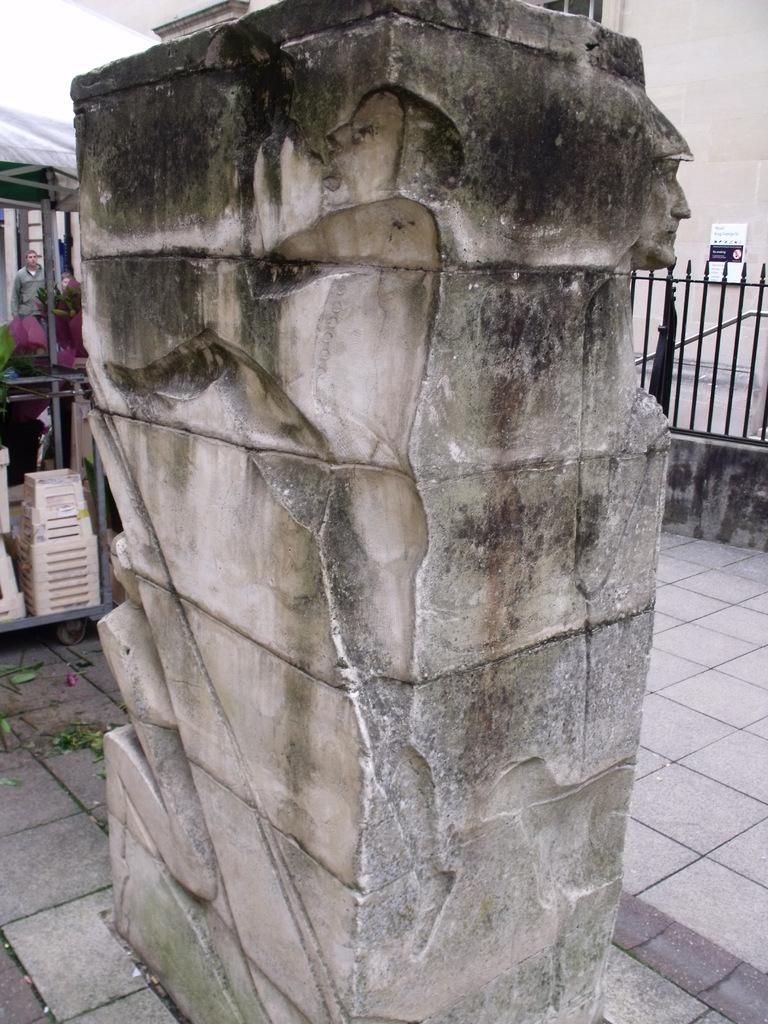What is the main feature in the center of the image? There is a wall with carvings in the center of the image. What can be seen in the background of the image? There is fencing in the background of the image. Are there any people visible in the image? Yes, there are people visible in the image. What is at the bottom of the image? There is a floor at the bottom of the image. What type of letter is being written by the people in the image? There is no letter being written in the image; the people are not engaged in any writing activity. 